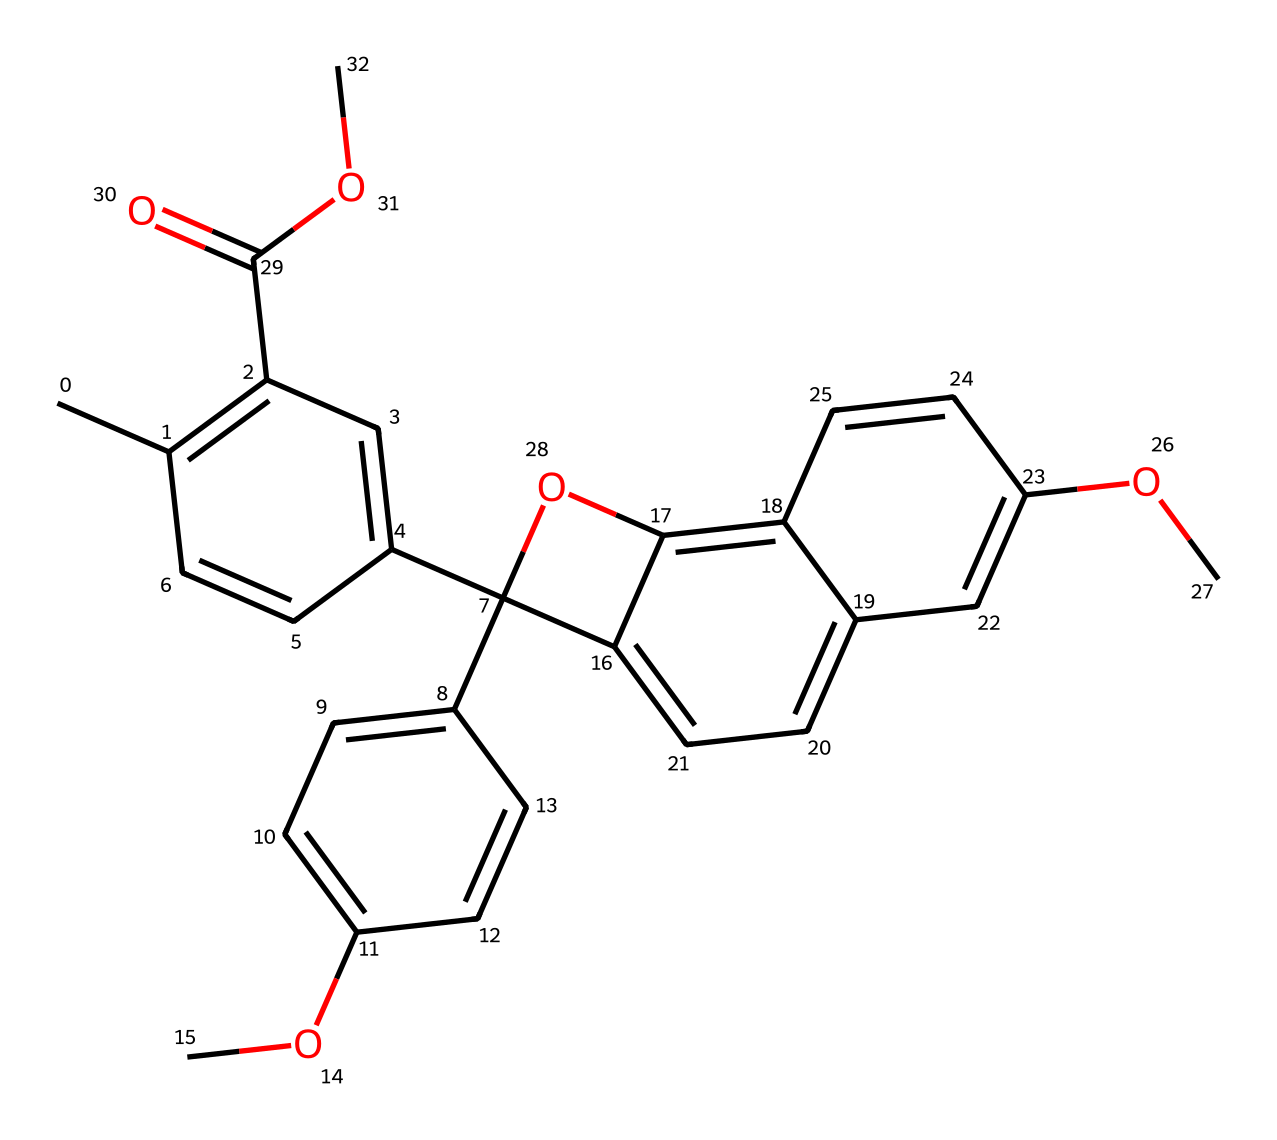what is the main functional group present in this compound? The compound contains an ester functional group noted by the presence of -C(=O)OC in the structure. This indicates that there are carbonyl (C=O) and ether (C-O) functionalities present.
Answer: ester how many rings are in the compound? By analyzing the SMILES representation, we observe the presence of multiple occurrences of ring closures (indicated by numbers in the SMILES). In this case, there are 4 distinct rings in the structure.
Answer: four what is the total number of carbon atoms in the structure? The SMILES representation can be deciphered to count the total number of carbon atoms. By counting all carbon symbols (C and occurrences from rings), there are 22 carbon atoms found in this chemical makeup.
Answer: twenty-two which type of light is this compound responsive to? Photochromic compounds are known to change their structure in response to ultraviolet light, which is high-energy light commonly associated with the UV spectrum.
Answer: ultraviolet is this compound likely to be soluble in water? Given that this compound contains several ring structures and ester groups, its hydrophilicity is limited. Generally, larger organic molecules with extensive aromatic systems tend to be less soluble in water.
Answer: no how does this chemical help in document preservation? Photochromic compounds can absorb UV light and undergo reversible structural changes, which minimize light exposure to sensitive documents, thus prolonging their longevity.
Answer: minimizes light exposure 